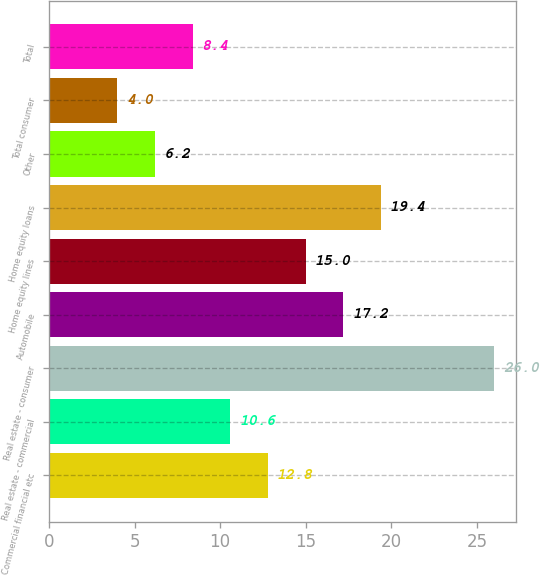Convert chart to OTSL. <chart><loc_0><loc_0><loc_500><loc_500><bar_chart><fcel>Commercial financial etc<fcel>Real estate - commercial<fcel>Real estate - consumer<fcel>Automobile<fcel>Home equity lines<fcel>Home equity loans<fcel>Other<fcel>Total consumer<fcel>Total<nl><fcel>12.8<fcel>10.6<fcel>26<fcel>17.2<fcel>15<fcel>19.4<fcel>6.2<fcel>4<fcel>8.4<nl></chart> 